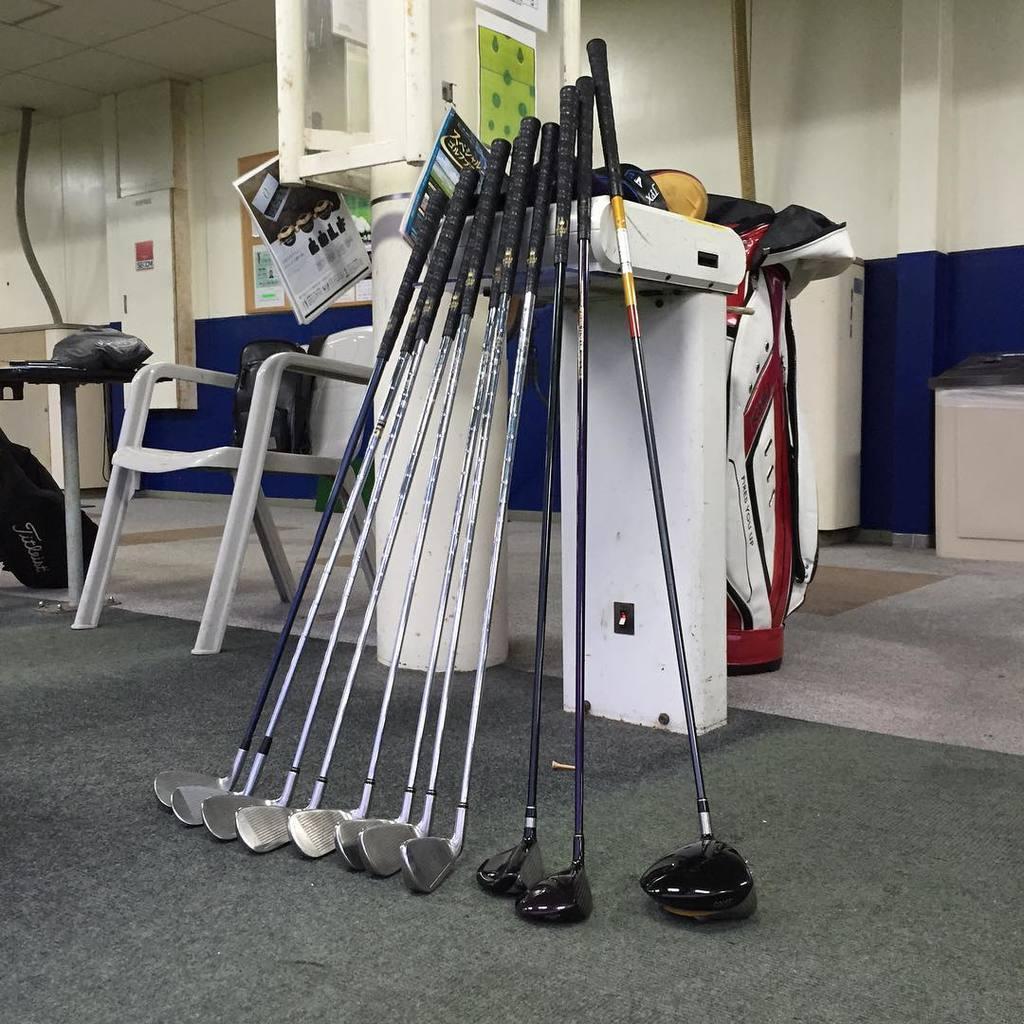How would you summarize this image in a sentence or two? In this image there is floor at the bottom. There is an object on the chair, there is a table, there are wooden objects on the wall in the left corner. There is a wooden object and there is a wall on the right corner. There are objects and posters in the foreground. It looks like a frame on the wall in the background. 